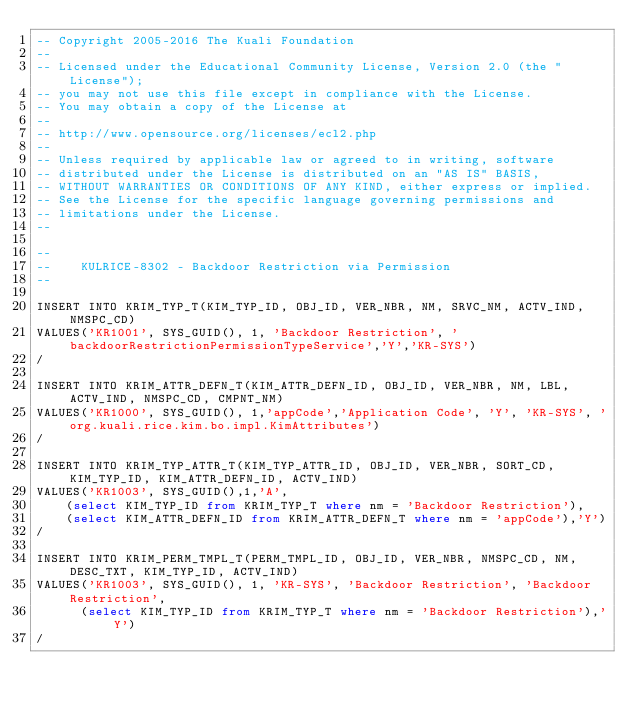<code> <loc_0><loc_0><loc_500><loc_500><_SQL_>-- Copyright 2005-2016 The Kuali Foundation
--
-- Licensed under the Educational Community License, Version 2.0 (the "License");
-- you may not use this file except in compliance with the License.
-- You may obtain a copy of the License at
--
-- http://www.opensource.org/licenses/ecl2.php
--
-- Unless required by applicable law or agreed to in writing, software
-- distributed under the License is distributed on an "AS IS" BASIS,
-- WITHOUT WARRANTIES OR CONDITIONS OF ANY KIND, either express or implied.
-- See the License for the specific language governing permissions and
-- limitations under the License.
--

--
--    KULRICE-8302 - Backdoor Restriction via Permission
--

INSERT INTO KRIM_TYP_T(KIM_TYP_ID, OBJ_ID, VER_NBR, NM, SRVC_NM, ACTV_IND, NMSPC_CD)
VALUES('KR1001', SYS_GUID(), 1, 'Backdoor Restriction', 'backdoorRestrictionPermissionTypeService','Y','KR-SYS')
/

INSERT INTO KRIM_ATTR_DEFN_T(KIM_ATTR_DEFN_ID, OBJ_ID, VER_NBR, NM, LBL, ACTV_IND, NMSPC_CD, CMPNT_NM)
VALUES('KR1000', SYS_GUID(), 1,'appCode','Application Code', 'Y', 'KR-SYS', 'org.kuali.rice.kim.bo.impl.KimAttributes')
/

INSERT INTO KRIM_TYP_ATTR_T(KIM_TYP_ATTR_ID, OBJ_ID, VER_NBR, SORT_CD, KIM_TYP_ID, KIM_ATTR_DEFN_ID, ACTV_IND)
VALUES('KR1003', SYS_GUID(),1,'A',
    (select KIM_TYP_ID from KRIM_TYP_T where nm = 'Backdoor Restriction'),
    (select KIM_ATTR_DEFN_ID from KRIM_ATTR_DEFN_T where nm = 'appCode'),'Y')
/

INSERT INTO KRIM_PERM_TMPL_T(PERM_TMPL_ID, OBJ_ID, VER_NBR, NMSPC_CD, NM, DESC_TXT, KIM_TYP_ID, ACTV_IND)
VALUES('KR1003', SYS_GUID(), 1, 'KR-SYS', 'Backdoor Restriction', 'Backdoor Restriction',
      (select KIM_TYP_ID from KRIM_TYP_T where nm = 'Backdoor Restriction'),'Y')
/
</code> 